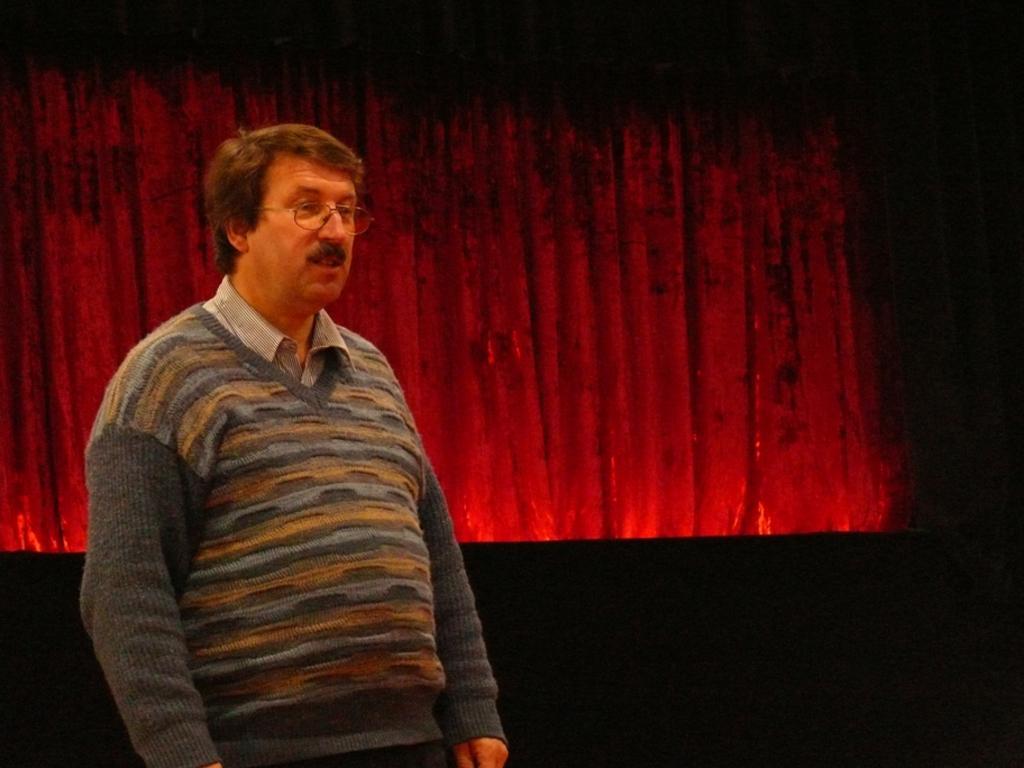Can you describe this image briefly? In this image there is a man standing on the stage behind him there is a red curtain. 